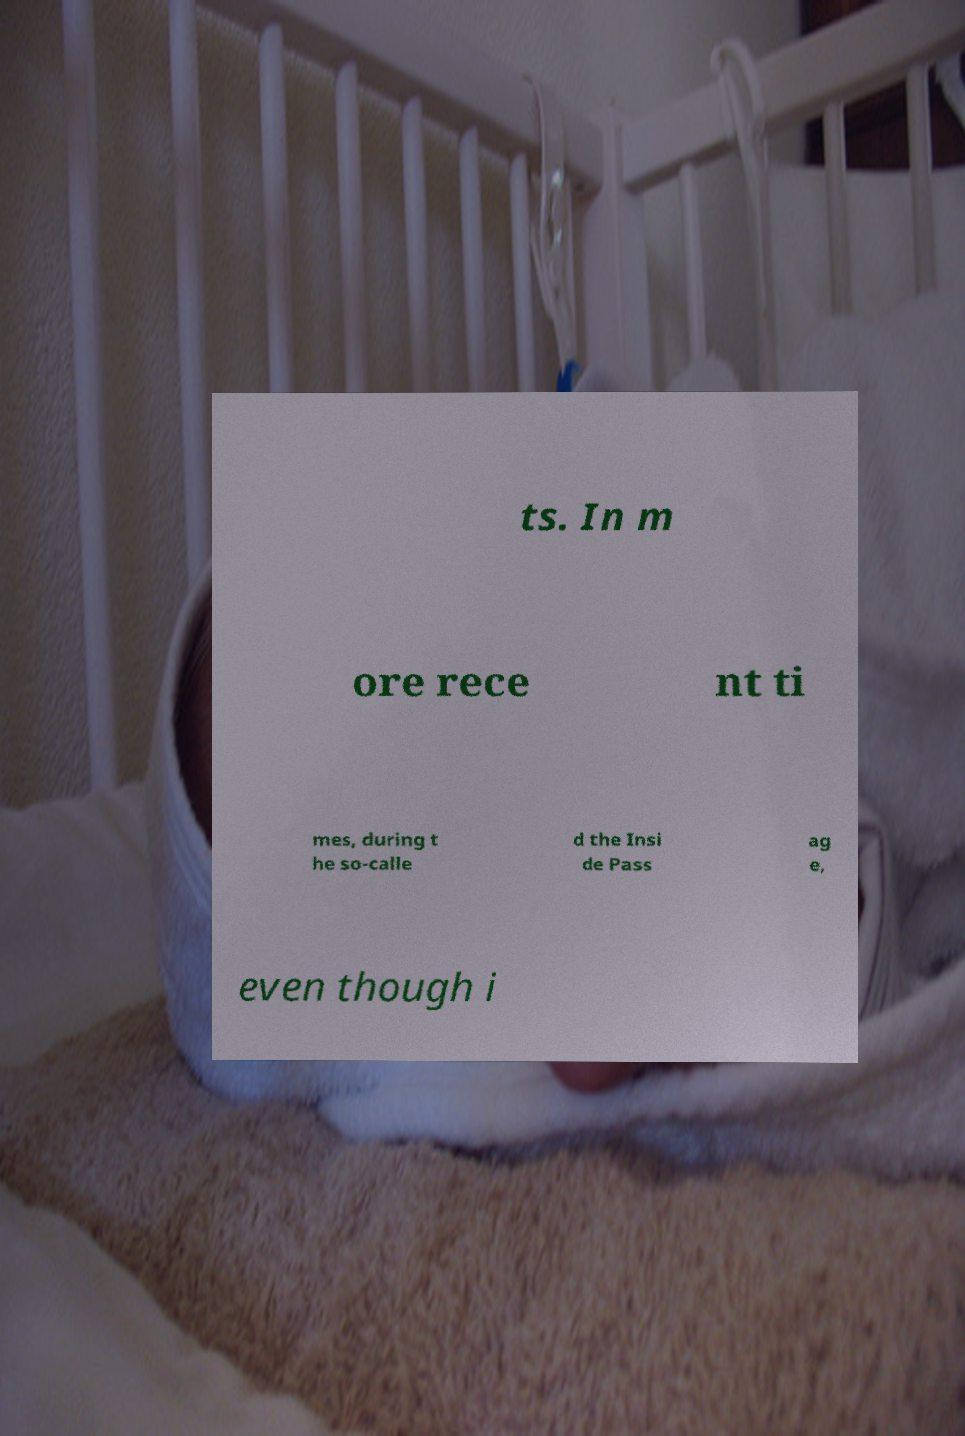What messages or text are displayed in this image? I need them in a readable, typed format. ts. In m ore rece nt ti mes, during t he so-calle d the Insi de Pass ag e, even though i 